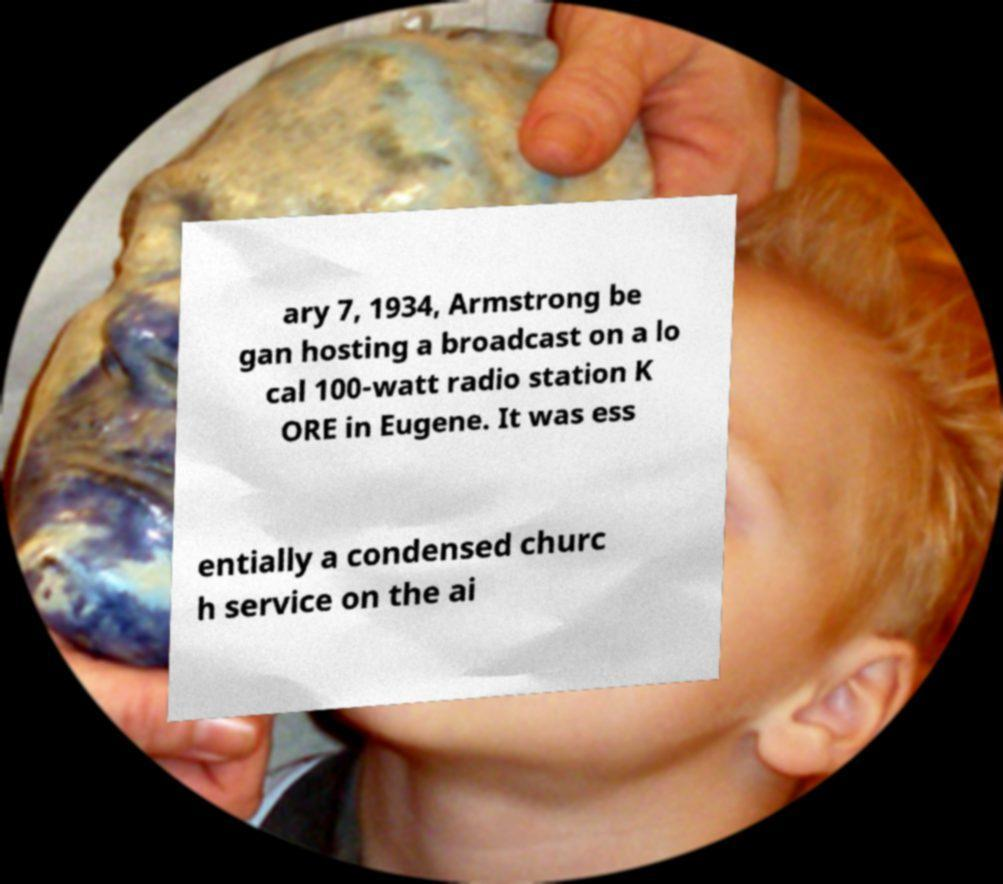For documentation purposes, I need the text within this image transcribed. Could you provide that? ary 7, 1934, Armstrong be gan hosting a broadcast on a lo cal 100-watt radio station K ORE in Eugene. It was ess entially a condensed churc h service on the ai 